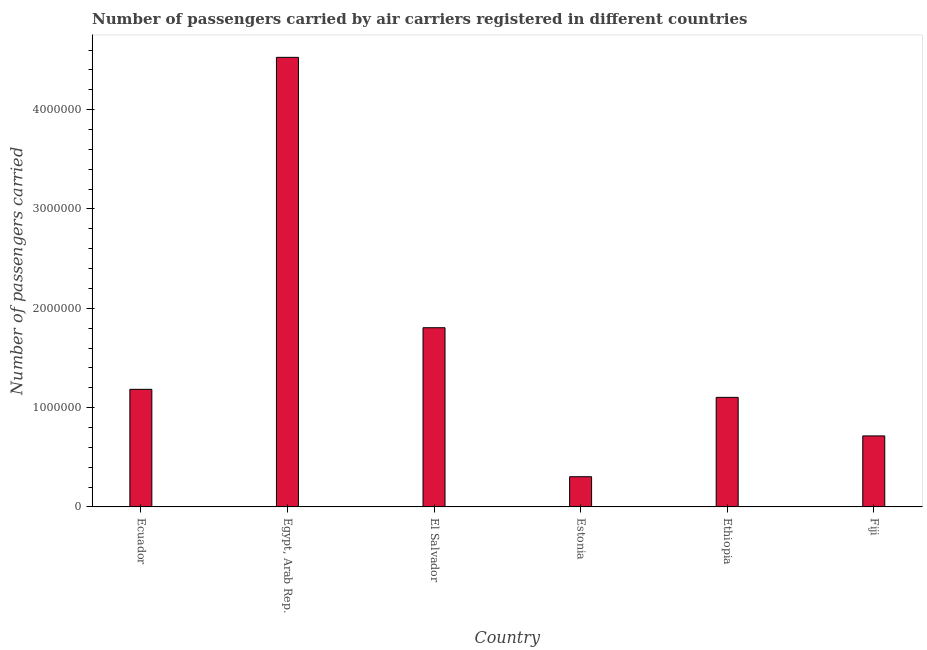What is the title of the graph?
Keep it short and to the point. Number of passengers carried by air carriers registered in different countries. What is the label or title of the X-axis?
Offer a very short reply. Country. What is the label or title of the Y-axis?
Keep it short and to the point. Number of passengers carried. What is the number of passengers carried in Fiji?
Make the answer very short. 7.15e+05. Across all countries, what is the maximum number of passengers carried?
Give a very brief answer. 4.53e+06. Across all countries, what is the minimum number of passengers carried?
Give a very brief answer. 3.04e+05. In which country was the number of passengers carried maximum?
Your answer should be compact. Egypt, Arab Rep. In which country was the number of passengers carried minimum?
Offer a terse response. Estonia. What is the sum of the number of passengers carried?
Provide a short and direct response. 9.64e+06. What is the difference between the number of passengers carried in Egypt, Arab Rep. and Ethiopia?
Provide a short and direct response. 3.42e+06. What is the average number of passengers carried per country?
Your answer should be compact. 1.61e+06. What is the median number of passengers carried?
Keep it short and to the point. 1.14e+06. In how many countries, is the number of passengers carried greater than 600000 ?
Ensure brevity in your answer.  5. What is the ratio of the number of passengers carried in Ecuador to that in Ethiopia?
Provide a succinct answer. 1.07. Is the number of passengers carried in Estonia less than that in Fiji?
Make the answer very short. Yes. What is the difference between the highest and the second highest number of passengers carried?
Provide a short and direct response. 2.72e+06. What is the difference between the highest and the lowest number of passengers carried?
Ensure brevity in your answer.  4.22e+06. How many countries are there in the graph?
Provide a short and direct response. 6. What is the difference between two consecutive major ticks on the Y-axis?
Provide a succinct answer. 1.00e+06. What is the Number of passengers carried in Ecuador?
Give a very brief answer. 1.18e+06. What is the Number of passengers carried in Egypt, Arab Rep.?
Make the answer very short. 4.53e+06. What is the Number of passengers carried of El Salvador?
Provide a succinct answer. 1.80e+06. What is the Number of passengers carried in Estonia?
Provide a short and direct response. 3.04e+05. What is the Number of passengers carried in Ethiopia?
Keep it short and to the point. 1.10e+06. What is the Number of passengers carried in Fiji?
Provide a succinct answer. 7.15e+05. What is the difference between the Number of passengers carried in Ecuador and Egypt, Arab Rep.?
Make the answer very short. -3.34e+06. What is the difference between the Number of passengers carried in Ecuador and El Salvador?
Your response must be concise. -6.20e+05. What is the difference between the Number of passengers carried in Ecuador and Estonia?
Keep it short and to the point. 8.80e+05. What is the difference between the Number of passengers carried in Ecuador and Ethiopia?
Provide a succinct answer. 8.09e+04. What is the difference between the Number of passengers carried in Ecuador and Fiji?
Your answer should be very brief. 4.69e+05. What is the difference between the Number of passengers carried in Egypt, Arab Rep. and El Salvador?
Provide a short and direct response. 2.72e+06. What is the difference between the Number of passengers carried in Egypt, Arab Rep. and Estonia?
Your answer should be compact. 4.22e+06. What is the difference between the Number of passengers carried in Egypt, Arab Rep. and Ethiopia?
Your answer should be very brief. 3.42e+06. What is the difference between the Number of passengers carried in Egypt, Arab Rep. and Fiji?
Your response must be concise. 3.81e+06. What is the difference between the Number of passengers carried in El Salvador and Estonia?
Offer a very short reply. 1.50e+06. What is the difference between the Number of passengers carried in El Salvador and Ethiopia?
Offer a terse response. 7.01e+05. What is the difference between the Number of passengers carried in El Salvador and Fiji?
Your answer should be compact. 1.09e+06. What is the difference between the Number of passengers carried in Estonia and Ethiopia?
Your answer should be compact. -7.99e+05. What is the difference between the Number of passengers carried in Estonia and Fiji?
Make the answer very short. -4.11e+05. What is the difference between the Number of passengers carried in Ethiopia and Fiji?
Keep it short and to the point. 3.88e+05. What is the ratio of the Number of passengers carried in Ecuador to that in Egypt, Arab Rep.?
Make the answer very short. 0.26. What is the ratio of the Number of passengers carried in Ecuador to that in El Salvador?
Keep it short and to the point. 0.66. What is the ratio of the Number of passengers carried in Ecuador to that in Estonia?
Offer a terse response. 3.89. What is the ratio of the Number of passengers carried in Ecuador to that in Ethiopia?
Provide a short and direct response. 1.07. What is the ratio of the Number of passengers carried in Ecuador to that in Fiji?
Offer a terse response. 1.66. What is the ratio of the Number of passengers carried in Egypt, Arab Rep. to that in El Salvador?
Ensure brevity in your answer.  2.51. What is the ratio of the Number of passengers carried in Egypt, Arab Rep. to that in Estonia?
Make the answer very short. 14.88. What is the ratio of the Number of passengers carried in Egypt, Arab Rep. to that in Ethiopia?
Offer a terse response. 4.1. What is the ratio of the Number of passengers carried in Egypt, Arab Rep. to that in Fiji?
Your response must be concise. 6.33. What is the ratio of the Number of passengers carried in El Salvador to that in Estonia?
Offer a very short reply. 5.93. What is the ratio of the Number of passengers carried in El Salvador to that in Ethiopia?
Your answer should be very brief. 1.64. What is the ratio of the Number of passengers carried in El Salvador to that in Fiji?
Give a very brief answer. 2.52. What is the ratio of the Number of passengers carried in Estonia to that in Ethiopia?
Offer a very short reply. 0.28. What is the ratio of the Number of passengers carried in Estonia to that in Fiji?
Give a very brief answer. 0.42. What is the ratio of the Number of passengers carried in Ethiopia to that in Fiji?
Ensure brevity in your answer.  1.54. 